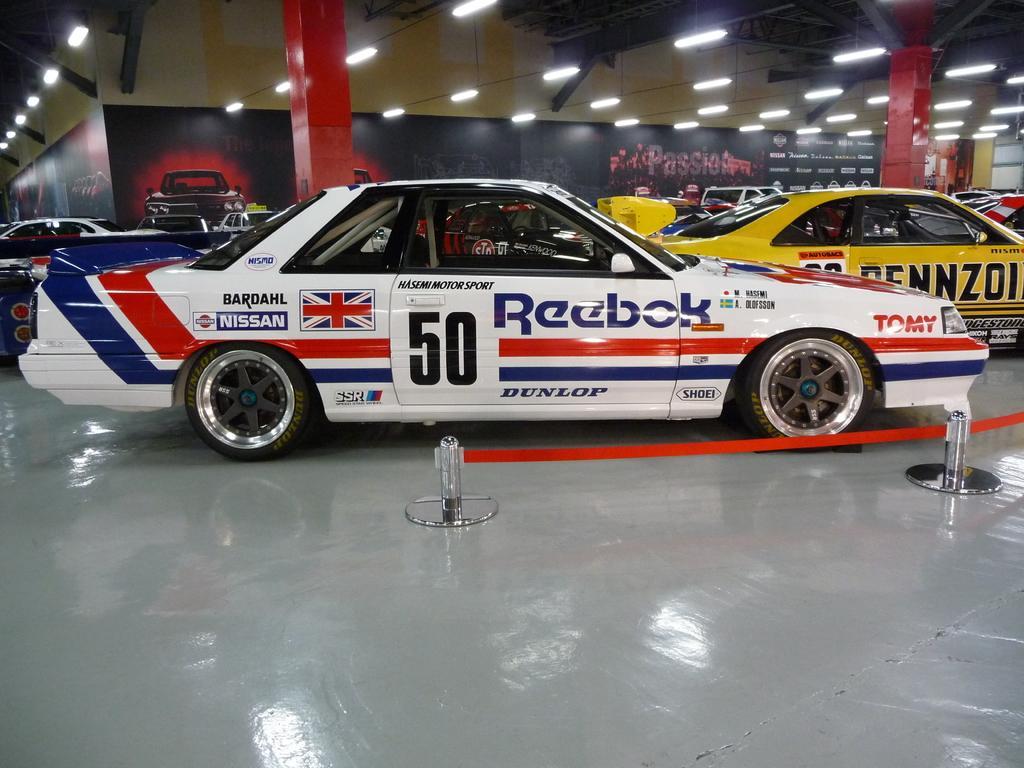Please provide a concise description of this image. In this image there are some cars in the middle of this image. There is a floor in the bottom of this image. There is a wall in the background. There are some lights arranged on the top of this image. 